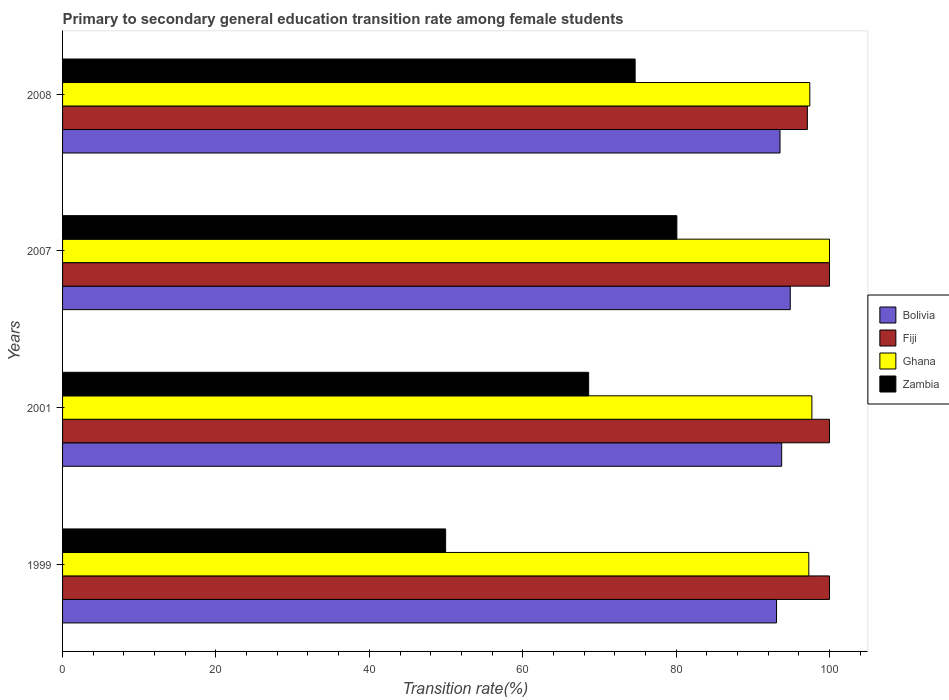How many groups of bars are there?
Offer a very short reply. 4. How many bars are there on the 4th tick from the bottom?
Your response must be concise. 4. What is the label of the 1st group of bars from the top?
Your answer should be very brief. 2008. In how many cases, is the number of bars for a given year not equal to the number of legend labels?
Provide a short and direct response. 0. What is the transition rate in Bolivia in 1999?
Make the answer very short. 93.09. Across all years, what is the maximum transition rate in Zambia?
Offer a terse response. 80.1. Across all years, what is the minimum transition rate in Zambia?
Give a very brief answer. 49.95. In which year was the transition rate in Fiji maximum?
Keep it short and to the point. 1999. In which year was the transition rate in Bolivia minimum?
Offer a very short reply. 1999. What is the total transition rate in Ghana in the graph?
Your answer should be compact. 392.43. What is the difference between the transition rate in Ghana in 1999 and that in 2007?
Provide a succinct answer. -2.7. What is the difference between the transition rate in Ghana in 2007 and the transition rate in Fiji in 1999?
Make the answer very short. 0. What is the average transition rate in Zambia per year?
Provide a short and direct response. 68.32. In the year 1999, what is the difference between the transition rate in Fiji and transition rate in Bolivia?
Ensure brevity in your answer.  6.91. What is the ratio of the transition rate in Fiji in 2007 to that in 2008?
Ensure brevity in your answer.  1.03. What is the difference between the highest and the lowest transition rate in Ghana?
Give a very brief answer. 2.7. Is the sum of the transition rate in Bolivia in 2001 and 2007 greater than the maximum transition rate in Fiji across all years?
Offer a very short reply. Yes. Is it the case that in every year, the sum of the transition rate in Zambia and transition rate in Bolivia is greater than the sum of transition rate in Ghana and transition rate in Fiji?
Keep it short and to the point. No. What does the 3rd bar from the top in 2008 represents?
Give a very brief answer. Fiji. What does the 4th bar from the bottom in 2007 represents?
Your response must be concise. Zambia. Is it the case that in every year, the sum of the transition rate in Ghana and transition rate in Bolivia is greater than the transition rate in Fiji?
Make the answer very short. Yes. How many bars are there?
Offer a terse response. 16. How many years are there in the graph?
Make the answer very short. 4. What is the difference between two consecutive major ticks on the X-axis?
Offer a very short reply. 20. Are the values on the major ticks of X-axis written in scientific E-notation?
Make the answer very short. No. Does the graph contain grids?
Offer a very short reply. No. How many legend labels are there?
Make the answer very short. 4. What is the title of the graph?
Provide a succinct answer. Primary to secondary general education transition rate among female students. Does "Northern Mariana Islands" appear as one of the legend labels in the graph?
Your answer should be compact. No. What is the label or title of the X-axis?
Your response must be concise. Transition rate(%). What is the Transition rate(%) of Bolivia in 1999?
Your response must be concise. 93.09. What is the Transition rate(%) of Ghana in 1999?
Ensure brevity in your answer.  97.3. What is the Transition rate(%) of Zambia in 1999?
Your response must be concise. 49.95. What is the Transition rate(%) in Bolivia in 2001?
Your answer should be very brief. 93.76. What is the Transition rate(%) in Fiji in 2001?
Make the answer very short. 100. What is the Transition rate(%) in Ghana in 2001?
Offer a terse response. 97.7. What is the Transition rate(%) in Zambia in 2001?
Offer a very short reply. 68.6. What is the Transition rate(%) of Bolivia in 2007?
Provide a succinct answer. 94.88. What is the Transition rate(%) of Ghana in 2007?
Your answer should be very brief. 100. What is the Transition rate(%) in Zambia in 2007?
Keep it short and to the point. 80.1. What is the Transition rate(%) in Bolivia in 2008?
Ensure brevity in your answer.  93.55. What is the Transition rate(%) of Fiji in 2008?
Your answer should be compact. 97.11. What is the Transition rate(%) in Ghana in 2008?
Your answer should be compact. 97.43. What is the Transition rate(%) in Zambia in 2008?
Provide a short and direct response. 74.66. Across all years, what is the maximum Transition rate(%) of Bolivia?
Offer a very short reply. 94.88. Across all years, what is the maximum Transition rate(%) in Ghana?
Offer a very short reply. 100. Across all years, what is the maximum Transition rate(%) in Zambia?
Make the answer very short. 80.1. Across all years, what is the minimum Transition rate(%) in Bolivia?
Your answer should be compact. 93.09. Across all years, what is the minimum Transition rate(%) in Fiji?
Ensure brevity in your answer.  97.11. Across all years, what is the minimum Transition rate(%) of Ghana?
Provide a succinct answer. 97.3. Across all years, what is the minimum Transition rate(%) of Zambia?
Your answer should be compact. 49.95. What is the total Transition rate(%) of Bolivia in the graph?
Your answer should be compact. 375.29. What is the total Transition rate(%) in Fiji in the graph?
Offer a very short reply. 397.11. What is the total Transition rate(%) of Ghana in the graph?
Provide a succinct answer. 392.43. What is the total Transition rate(%) of Zambia in the graph?
Keep it short and to the point. 273.3. What is the difference between the Transition rate(%) in Bolivia in 1999 and that in 2001?
Offer a terse response. -0.67. What is the difference between the Transition rate(%) of Fiji in 1999 and that in 2001?
Your answer should be very brief. 0. What is the difference between the Transition rate(%) in Ghana in 1999 and that in 2001?
Your answer should be compact. -0.4. What is the difference between the Transition rate(%) in Zambia in 1999 and that in 2001?
Ensure brevity in your answer.  -18.65. What is the difference between the Transition rate(%) in Bolivia in 1999 and that in 2007?
Make the answer very short. -1.79. What is the difference between the Transition rate(%) in Ghana in 1999 and that in 2007?
Offer a terse response. -2.7. What is the difference between the Transition rate(%) of Zambia in 1999 and that in 2007?
Your response must be concise. -30.15. What is the difference between the Transition rate(%) of Bolivia in 1999 and that in 2008?
Provide a short and direct response. -0.45. What is the difference between the Transition rate(%) in Fiji in 1999 and that in 2008?
Your answer should be very brief. 2.89. What is the difference between the Transition rate(%) of Ghana in 1999 and that in 2008?
Your response must be concise. -0.13. What is the difference between the Transition rate(%) of Zambia in 1999 and that in 2008?
Your answer should be compact. -24.71. What is the difference between the Transition rate(%) in Bolivia in 2001 and that in 2007?
Ensure brevity in your answer.  -1.12. What is the difference between the Transition rate(%) of Fiji in 2001 and that in 2007?
Keep it short and to the point. 0. What is the difference between the Transition rate(%) in Ghana in 2001 and that in 2007?
Provide a succinct answer. -2.3. What is the difference between the Transition rate(%) in Zambia in 2001 and that in 2007?
Give a very brief answer. -11.5. What is the difference between the Transition rate(%) in Bolivia in 2001 and that in 2008?
Provide a succinct answer. 0.22. What is the difference between the Transition rate(%) of Fiji in 2001 and that in 2008?
Offer a terse response. 2.89. What is the difference between the Transition rate(%) in Ghana in 2001 and that in 2008?
Provide a short and direct response. 0.27. What is the difference between the Transition rate(%) in Zambia in 2001 and that in 2008?
Provide a short and direct response. -6.06. What is the difference between the Transition rate(%) of Bolivia in 2007 and that in 2008?
Make the answer very short. 1.33. What is the difference between the Transition rate(%) of Fiji in 2007 and that in 2008?
Offer a very short reply. 2.89. What is the difference between the Transition rate(%) in Ghana in 2007 and that in 2008?
Offer a terse response. 2.57. What is the difference between the Transition rate(%) of Zambia in 2007 and that in 2008?
Your answer should be very brief. 5.44. What is the difference between the Transition rate(%) of Bolivia in 1999 and the Transition rate(%) of Fiji in 2001?
Ensure brevity in your answer.  -6.91. What is the difference between the Transition rate(%) in Bolivia in 1999 and the Transition rate(%) in Ghana in 2001?
Your response must be concise. -4.61. What is the difference between the Transition rate(%) of Bolivia in 1999 and the Transition rate(%) of Zambia in 2001?
Your response must be concise. 24.5. What is the difference between the Transition rate(%) of Fiji in 1999 and the Transition rate(%) of Ghana in 2001?
Keep it short and to the point. 2.3. What is the difference between the Transition rate(%) in Fiji in 1999 and the Transition rate(%) in Zambia in 2001?
Offer a very short reply. 31.4. What is the difference between the Transition rate(%) of Ghana in 1999 and the Transition rate(%) of Zambia in 2001?
Offer a very short reply. 28.7. What is the difference between the Transition rate(%) of Bolivia in 1999 and the Transition rate(%) of Fiji in 2007?
Provide a short and direct response. -6.91. What is the difference between the Transition rate(%) of Bolivia in 1999 and the Transition rate(%) of Ghana in 2007?
Offer a terse response. -6.91. What is the difference between the Transition rate(%) in Bolivia in 1999 and the Transition rate(%) in Zambia in 2007?
Give a very brief answer. 13. What is the difference between the Transition rate(%) in Fiji in 1999 and the Transition rate(%) in Zambia in 2007?
Your answer should be compact. 19.9. What is the difference between the Transition rate(%) in Ghana in 1999 and the Transition rate(%) in Zambia in 2007?
Your response must be concise. 17.2. What is the difference between the Transition rate(%) in Bolivia in 1999 and the Transition rate(%) in Fiji in 2008?
Ensure brevity in your answer.  -4.02. What is the difference between the Transition rate(%) of Bolivia in 1999 and the Transition rate(%) of Ghana in 2008?
Offer a very short reply. -4.34. What is the difference between the Transition rate(%) of Bolivia in 1999 and the Transition rate(%) of Zambia in 2008?
Give a very brief answer. 18.44. What is the difference between the Transition rate(%) of Fiji in 1999 and the Transition rate(%) of Ghana in 2008?
Make the answer very short. 2.57. What is the difference between the Transition rate(%) of Fiji in 1999 and the Transition rate(%) of Zambia in 2008?
Offer a terse response. 25.34. What is the difference between the Transition rate(%) of Ghana in 1999 and the Transition rate(%) of Zambia in 2008?
Your answer should be compact. 22.64. What is the difference between the Transition rate(%) of Bolivia in 2001 and the Transition rate(%) of Fiji in 2007?
Your response must be concise. -6.24. What is the difference between the Transition rate(%) of Bolivia in 2001 and the Transition rate(%) of Ghana in 2007?
Offer a terse response. -6.24. What is the difference between the Transition rate(%) in Bolivia in 2001 and the Transition rate(%) in Zambia in 2007?
Your response must be concise. 13.67. What is the difference between the Transition rate(%) in Fiji in 2001 and the Transition rate(%) in Zambia in 2007?
Keep it short and to the point. 19.9. What is the difference between the Transition rate(%) in Ghana in 2001 and the Transition rate(%) in Zambia in 2007?
Give a very brief answer. 17.61. What is the difference between the Transition rate(%) in Bolivia in 2001 and the Transition rate(%) in Fiji in 2008?
Your answer should be very brief. -3.35. What is the difference between the Transition rate(%) of Bolivia in 2001 and the Transition rate(%) of Ghana in 2008?
Provide a succinct answer. -3.67. What is the difference between the Transition rate(%) of Bolivia in 2001 and the Transition rate(%) of Zambia in 2008?
Make the answer very short. 19.11. What is the difference between the Transition rate(%) of Fiji in 2001 and the Transition rate(%) of Ghana in 2008?
Your answer should be compact. 2.57. What is the difference between the Transition rate(%) of Fiji in 2001 and the Transition rate(%) of Zambia in 2008?
Ensure brevity in your answer.  25.34. What is the difference between the Transition rate(%) in Ghana in 2001 and the Transition rate(%) in Zambia in 2008?
Your answer should be very brief. 23.05. What is the difference between the Transition rate(%) of Bolivia in 2007 and the Transition rate(%) of Fiji in 2008?
Provide a short and direct response. -2.23. What is the difference between the Transition rate(%) of Bolivia in 2007 and the Transition rate(%) of Ghana in 2008?
Give a very brief answer. -2.55. What is the difference between the Transition rate(%) in Bolivia in 2007 and the Transition rate(%) in Zambia in 2008?
Keep it short and to the point. 20.23. What is the difference between the Transition rate(%) in Fiji in 2007 and the Transition rate(%) in Ghana in 2008?
Offer a very short reply. 2.57. What is the difference between the Transition rate(%) of Fiji in 2007 and the Transition rate(%) of Zambia in 2008?
Your answer should be very brief. 25.34. What is the difference between the Transition rate(%) in Ghana in 2007 and the Transition rate(%) in Zambia in 2008?
Give a very brief answer. 25.34. What is the average Transition rate(%) in Bolivia per year?
Ensure brevity in your answer.  93.82. What is the average Transition rate(%) in Fiji per year?
Give a very brief answer. 99.28. What is the average Transition rate(%) of Ghana per year?
Make the answer very short. 98.11. What is the average Transition rate(%) in Zambia per year?
Make the answer very short. 68.32. In the year 1999, what is the difference between the Transition rate(%) of Bolivia and Transition rate(%) of Fiji?
Offer a terse response. -6.91. In the year 1999, what is the difference between the Transition rate(%) of Bolivia and Transition rate(%) of Ghana?
Your answer should be very brief. -4.21. In the year 1999, what is the difference between the Transition rate(%) in Bolivia and Transition rate(%) in Zambia?
Give a very brief answer. 43.14. In the year 1999, what is the difference between the Transition rate(%) of Fiji and Transition rate(%) of Ghana?
Ensure brevity in your answer.  2.7. In the year 1999, what is the difference between the Transition rate(%) of Fiji and Transition rate(%) of Zambia?
Give a very brief answer. 50.05. In the year 1999, what is the difference between the Transition rate(%) of Ghana and Transition rate(%) of Zambia?
Your response must be concise. 47.35. In the year 2001, what is the difference between the Transition rate(%) of Bolivia and Transition rate(%) of Fiji?
Your answer should be very brief. -6.24. In the year 2001, what is the difference between the Transition rate(%) of Bolivia and Transition rate(%) of Ghana?
Ensure brevity in your answer.  -3.94. In the year 2001, what is the difference between the Transition rate(%) of Bolivia and Transition rate(%) of Zambia?
Make the answer very short. 25.17. In the year 2001, what is the difference between the Transition rate(%) in Fiji and Transition rate(%) in Ghana?
Your answer should be compact. 2.3. In the year 2001, what is the difference between the Transition rate(%) of Fiji and Transition rate(%) of Zambia?
Provide a short and direct response. 31.4. In the year 2001, what is the difference between the Transition rate(%) in Ghana and Transition rate(%) in Zambia?
Offer a terse response. 29.11. In the year 2007, what is the difference between the Transition rate(%) of Bolivia and Transition rate(%) of Fiji?
Keep it short and to the point. -5.12. In the year 2007, what is the difference between the Transition rate(%) of Bolivia and Transition rate(%) of Ghana?
Your answer should be very brief. -5.12. In the year 2007, what is the difference between the Transition rate(%) in Bolivia and Transition rate(%) in Zambia?
Keep it short and to the point. 14.79. In the year 2007, what is the difference between the Transition rate(%) of Fiji and Transition rate(%) of Zambia?
Provide a succinct answer. 19.9. In the year 2007, what is the difference between the Transition rate(%) in Ghana and Transition rate(%) in Zambia?
Your answer should be compact. 19.9. In the year 2008, what is the difference between the Transition rate(%) of Bolivia and Transition rate(%) of Fiji?
Give a very brief answer. -3.56. In the year 2008, what is the difference between the Transition rate(%) in Bolivia and Transition rate(%) in Ghana?
Your response must be concise. -3.88. In the year 2008, what is the difference between the Transition rate(%) in Bolivia and Transition rate(%) in Zambia?
Offer a very short reply. 18.89. In the year 2008, what is the difference between the Transition rate(%) of Fiji and Transition rate(%) of Ghana?
Ensure brevity in your answer.  -0.32. In the year 2008, what is the difference between the Transition rate(%) in Fiji and Transition rate(%) in Zambia?
Ensure brevity in your answer.  22.45. In the year 2008, what is the difference between the Transition rate(%) of Ghana and Transition rate(%) of Zambia?
Offer a very short reply. 22.77. What is the ratio of the Transition rate(%) of Bolivia in 1999 to that in 2001?
Ensure brevity in your answer.  0.99. What is the ratio of the Transition rate(%) of Fiji in 1999 to that in 2001?
Provide a short and direct response. 1. What is the ratio of the Transition rate(%) of Ghana in 1999 to that in 2001?
Keep it short and to the point. 1. What is the ratio of the Transition rate(%) of Zambia in 1999 to that in 2001?
Offer a very short reply. 0.73. What is the ratio of the Transition rate(%) of Bolivia in 1999 to that in 2007?
Give a very brief answer. 0.98. What is the ratio of the Transition rate(%) of Zambia in 1999 to that in 2007?
Your response must be concise. 0.62. What is the ratio of the Transition rate(%) in Fiji in 1999 to that in 2008?
Your answer should be compact. 1.03. What is the ratio of the Transition rate(%) of Ghana in 1999 to that in 2008?
Your response must be concise. 1. What is the ratio of the Transition rate(%) in Zambia in 1999 to that in 2008?
Give a very brief answer. 0.67. What is the ratio of the Transition rate(%) in Ghana in 2001 to that in 2007?
Make the answer very short. 0.98. What is the ratio of the Transition rate(%) of Zambia in 2001 to that in 2007?
Offer a very short reply. 0.86. What is the ratio of the Transition rate(%) in Bolivia in 2001 to that in 2008?
Your response must be concise. 1. What is the ratio of the Transition rate(%) in Fiji in 2001 to that in 2008?
Make the answer very short. 1.03. What is the ratio of the Transition rate(%) in Ghana in 2001 to that in 2008?
Offer a very short reply. 1. What is the ratio of the Transition rate(%) in Zambia in 2001 to that in 2008?
Your response must be concise. 0.92. What is the ratio of the Transition rate(%) of Bolivia in 2007 to that in 2008?
Keep it short and to the point. 1.01. What is the ratio of the Transition rate(%) in Fiji in 2007 to that in 2008?
Keep it short and to the point. 1.03. What is the ratio of the Transition rate(%) in Ghana in 2007 to that in 2008?
Keep it short and to the point. 1.03. What is the ratio of the Transition rate(%) in Zambia in 2007 to that in 2008?
Your answer should be compact. 1.07. What is the difference between the highest and the second highest Transition rate(%) in Bolivia?
Provide a succinct answer. 1.12. What is the difference between the highest and the second highest Transition rate(%) in Ghana?
Offer a terse response. 2.3. What is the difference between the highest and the second highest Transition rate(%) of Zambia?
Provide a succinct answer. 5.44. What is the difference between the highest and the lowest Transition rate(%) in Bolivia?
Your answer should be very brief. 1.79. What is the difference between the highest and the lowest Transition rate(%) in Fiji?
Your answer should be compact. 2.89. What is the difference between the highest and the lowest Transition rate(%) of Ghana?
Provide a short and direct response. 2.7. What is the difference between the highest and the lowest Transition rate(%) in Zambia?
Offer a terse response. 30.15. 